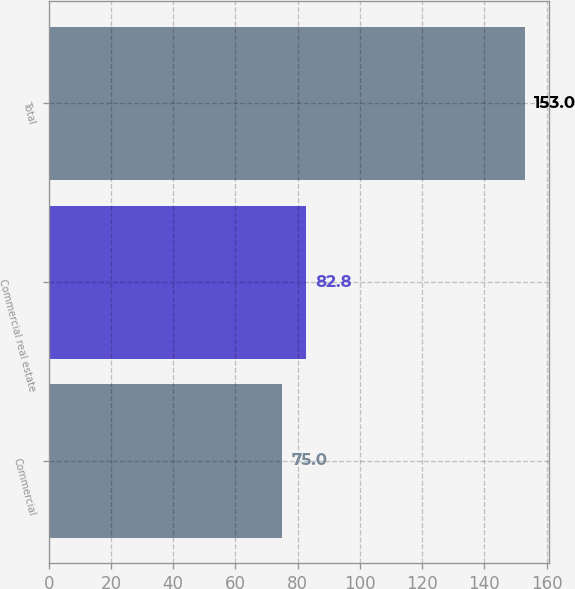Convert chart. <chart><loc_0><loc_0><loc_500><loc_500><bar_chart><fcel>Commercial<fcel>Commercial real estate<fcel>Total<nl><fcel>75<fcel>82.8<fcel>153<nl></chart> 